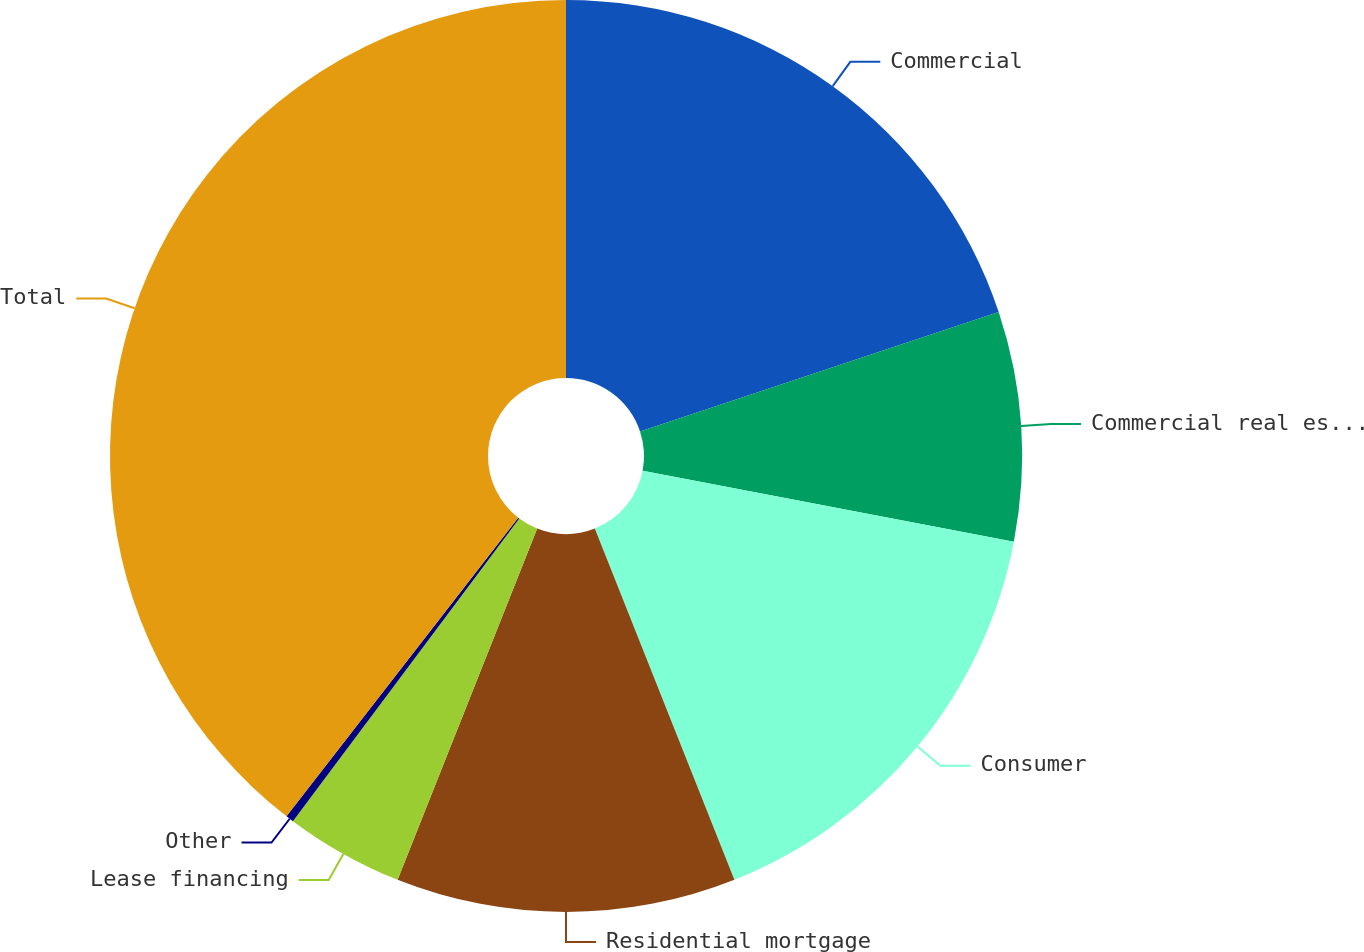<chart> <loc_0><loc_0><loc_500><loc_500><pie_chart><fcel>Commercial<fcel>Commercial real estate<fcel>Consumer<fcel>Residential mortgage<fcel>Lease financing<fcel>Other<fcel>Total<nl><fcel>19.89%<fcel>8.12%<fcel>15.97%<fcel>12.04%<fcel>4.2%<fcel>0.28%<fcel>39.5%<nl></chart> 